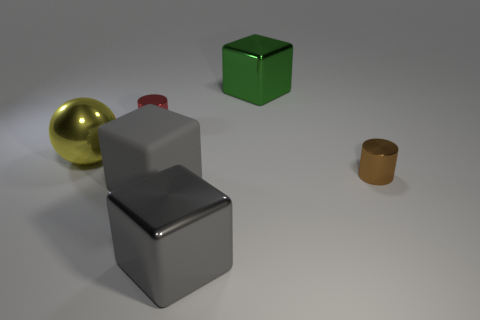Is there any other thing that is the same shape as the yellow metal thing?
Your response must be concise. No. There is a large ball; is its color the same as the tiny object left of the large rubber object?
Your response must be concise. No. What is the size of the green object that is the same shape as the large gray matte thing?
Offer a terse response. Large. What shape is the big object that is both right of the large matte object and in front of the ball?
Your answer should be very brief. Cube. There is a red metallic object; is its size the same as the brown shiny object that is behind the rubber cube?
Provide a short and direct response. Yes. There is a matte object that is the same shape as the large green metallic thing; what is its color?
Keep it short and to the point. Gray. There is a metallic cube in front of the green cube; is it the same size as the shiny cylinder that is behind the small brown shiny cylinder?
Your answer should be very brief. No. Does the big green thing have the same shape as the big gray matte thing?
Offer a very short reply. Yes. What number of objects are tiny things behind the big sphere or small gray metal objects?
Make the answer very short. 1. Is there a red metallic thing of the same shape as the tiny brown object?
Provide a short and direct response. Yes. 